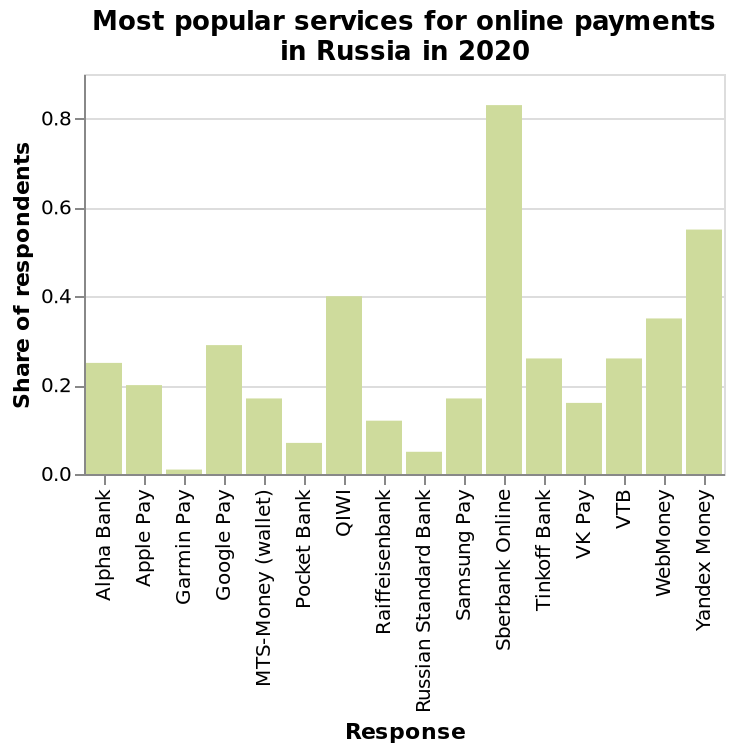<image>
Is Sberbank online popular among users? Yes, Sberbank online is highly regarded. please summary the statistics and relations of the chart I cannot see any trends of patterns. Sberbank online is clearly the best. Almost no one uses Garmin Pay. please enumerates aspects of the construction of the chart Most popular services for online payments in Russia in 2020 is a bar chart. The y-axis measures Share of respondents while the x-axis plots Response. 